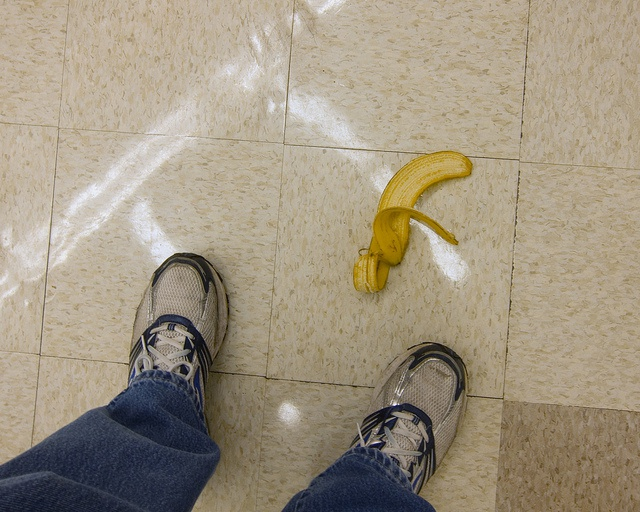Describe the objects in this image and their specific colors. I can see people in tan, black, gray, and darkgray tones and banana in tan and olive tones in this image. 